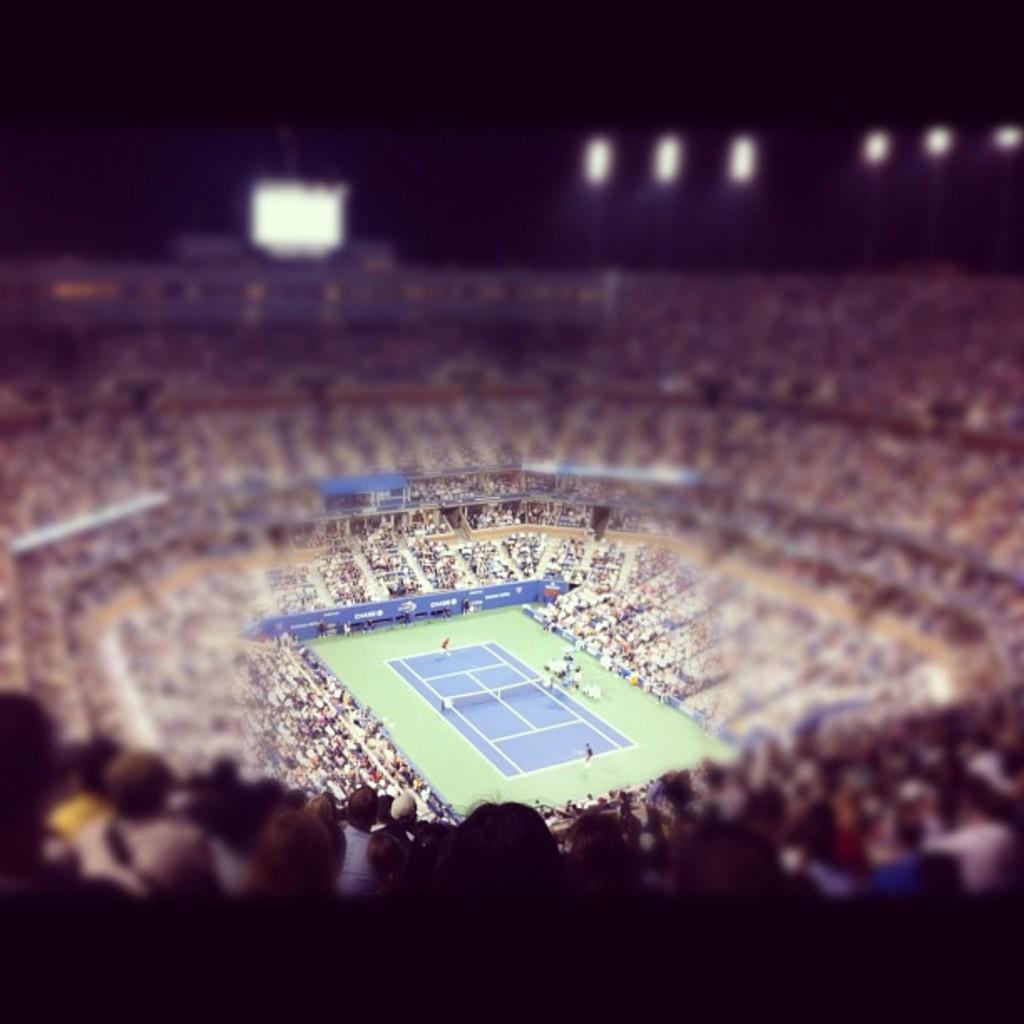Can you describe this image briefly? In this picture, we can see a view from the stadium, we can see a few people, posters, ground, lights and the blurred background. 